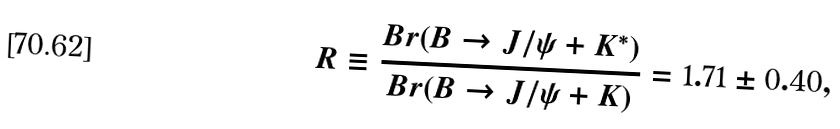Convert formula to latex. <formula><loc_0><loc_0><loc_500><loc_500>R \equiv \frac { B r ( B \rightarrow J / \psi + K ^ { * } ) } { B r ( B \rightarrow J / \psi + K ) } = 1 . 7 1 \pm 0 . 4 0 ,</formula> 